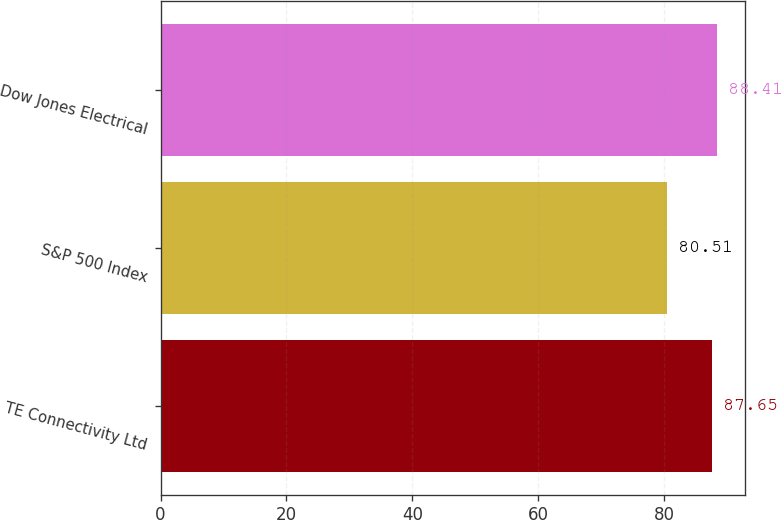Convert chart. <chart><loc_0><loc_0><loc_500><loc_500><bar_chart><fcel>TE Connectivity Ltd<fcel>S&P 500 Index<fcel>Dow Jones Electrical<nl><fcel>87.65<fcel>80.51<fcel>88.41<nl></chart> 